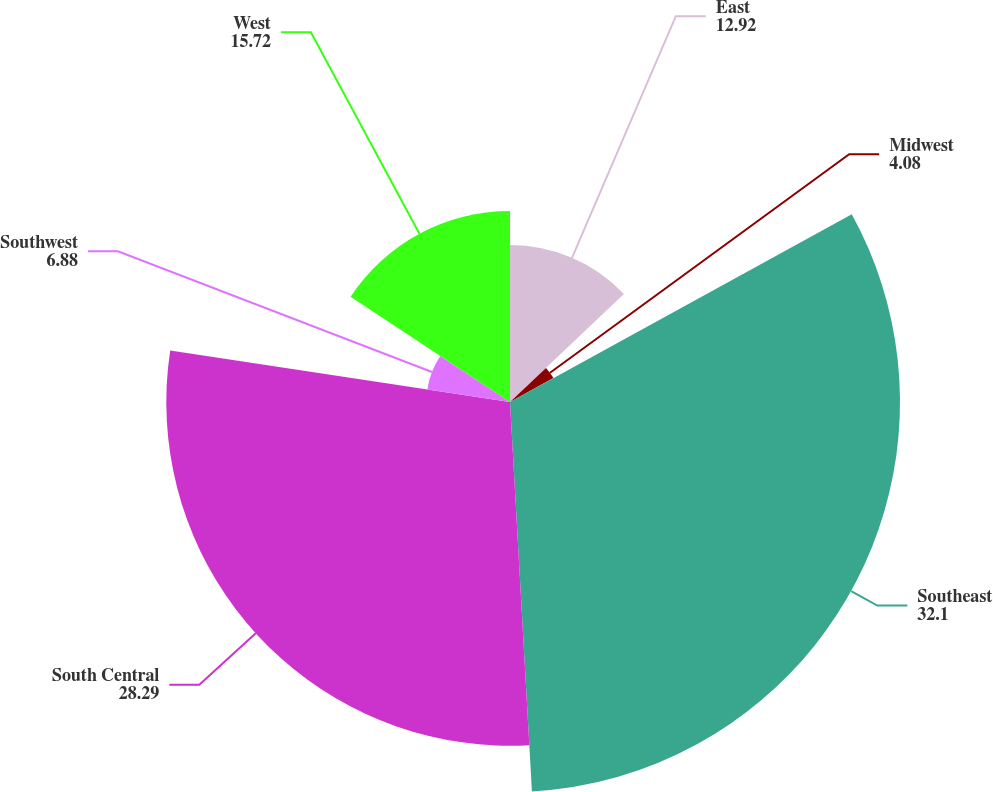Convert chart to OTSL. <chart><loc_0><loc_0><loc_500><loc_500><pie_chart><fcel>East<fcel>Midwest<fcel>Southeast<fcel>South Central<fcel>Southwest<fcel>West<nl><fcel>12.92%<fcel>4.08%<fcel>32.1%<fcel>28.29%<fcel>6.88%<fcel>15.72%<nl></chart> 